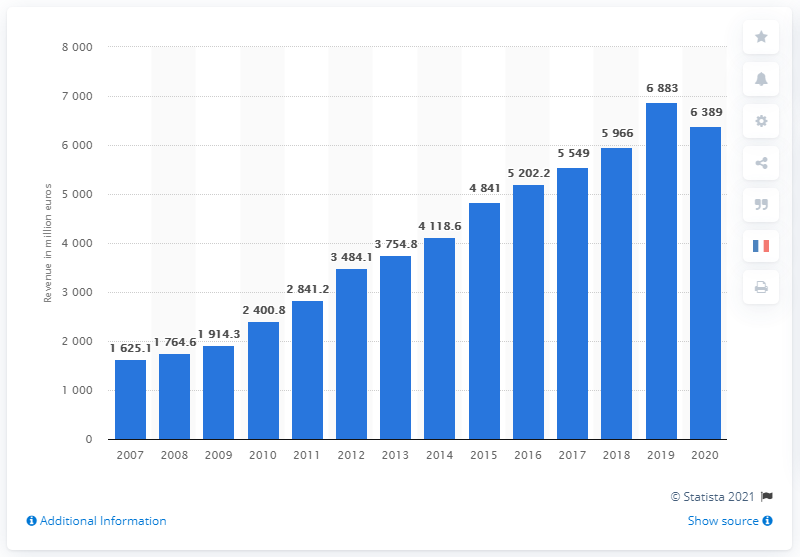Indicate a few pertinent items in this graphic. Herm's revenue decreased by 6883 in 2019. In 2019, the total revenue of Herm's worldwide was 6,883. 